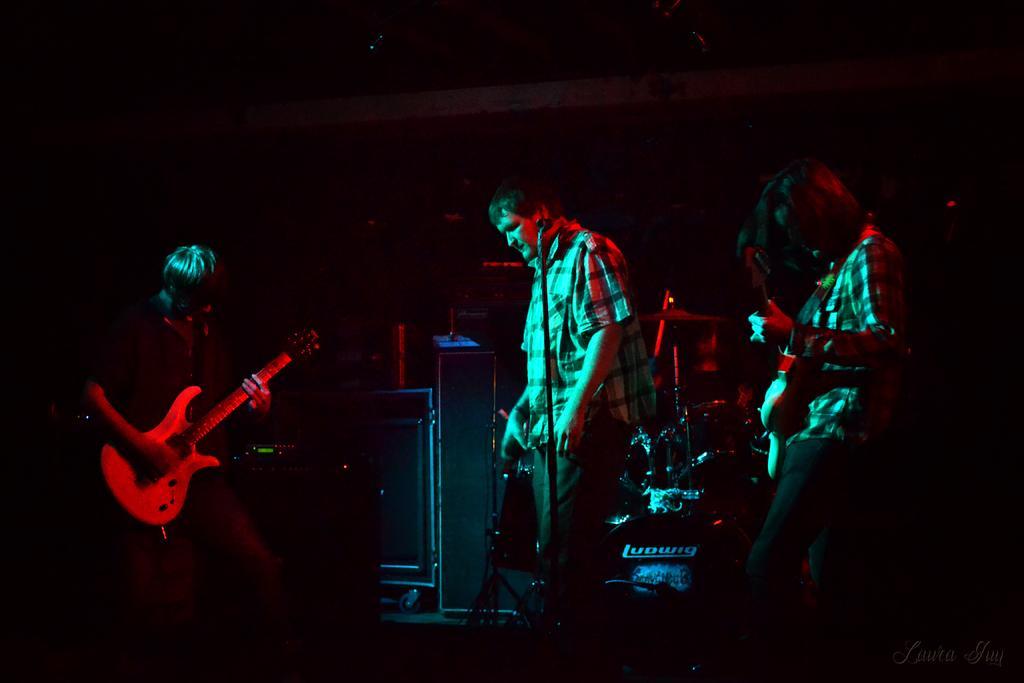How would you summarize this image in a sentence or two? In this image we can see some group of persons standing and playing musical instruments and at the background of the image there are some sound boxes. 